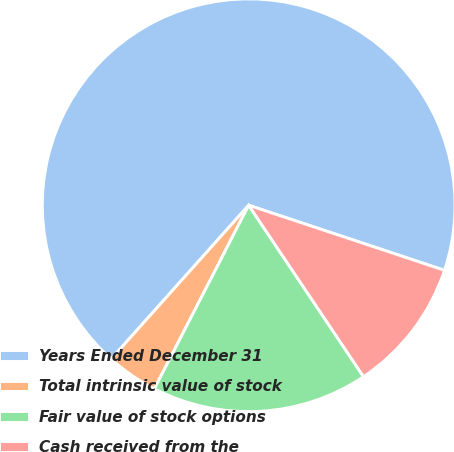<chart> <loc_0><loc_0><loc_500><loc_500><pie_chart><fcel>Years Ended December 31<fcel>Total intrinsic value of stock<fcel>Fair value of stock options<fcel>Cash received from the<nl><fcel>68.5%<fcel>4.06%<fcel>16.95%<fcel>10.5%<nl></chart> 